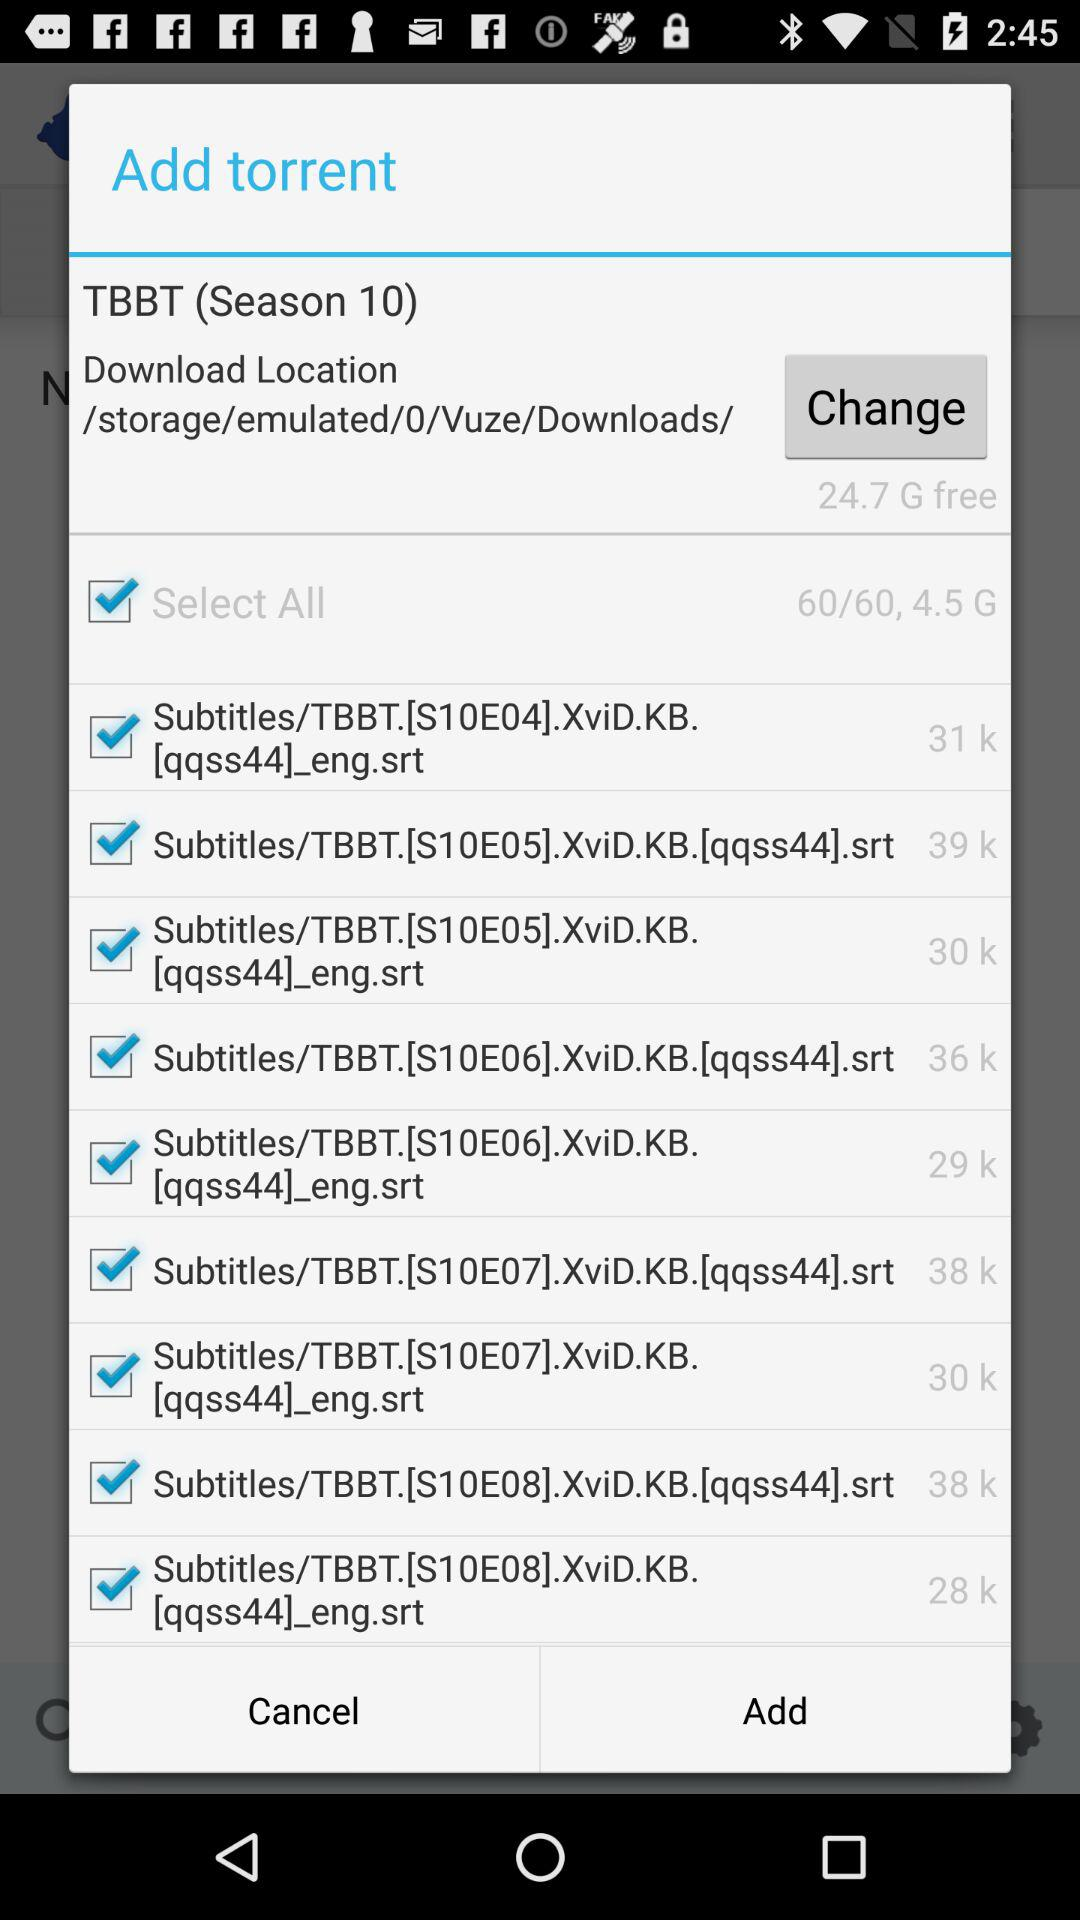What download location is selected? The download location is "/storage/emulated/0/Vuze/Downloads/". 